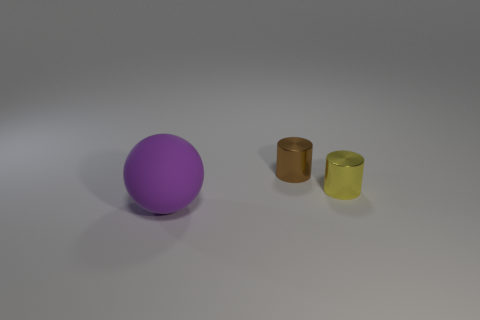Is there any other thing that has the same shape as the rubber thing?
Offer a very short reply. No. How many objects are metal things behind the tiny yellow cylinder or tiny yellow metallic things?
Offer a very short reply. 2. What material is the object that is on the left side of the metallic cylinder behind the small shiny thing to the right of the brown metallic cylinder?
Keep it short and to the point. Rubber. Is the number of brown cylinders left of the large purple matte object greater than the number of shiny objects that are on the right side of the brown metallic thing?
Keep it short and to the point. No. How many cylinders are yellow metallic things or tiny brown shiny objects?
Provide a succinct answer. 2. What number of large matte things are in front of the cylinder in front of the tiny metallic cylinder behind the tiny yellow cylinder?
Keep it short and to the point. 1. Is the number of tiny brown metal cylinders greater than the number of tiny yellow shiny spheres?
Your response must be concise. Yes. Is the size of the matte thing the same as the brown object?
Ensure brevity in your answer.  No. How many things are either yellow matte cylinders or tiny shiny cylinders?
Provide a succinct answer. 2. What is the shape of the thing that is in front of the cylinder that is right of the metal cylinder that is on the left side of the yellow metallic object?
Offer a very short reply. Sphere. 